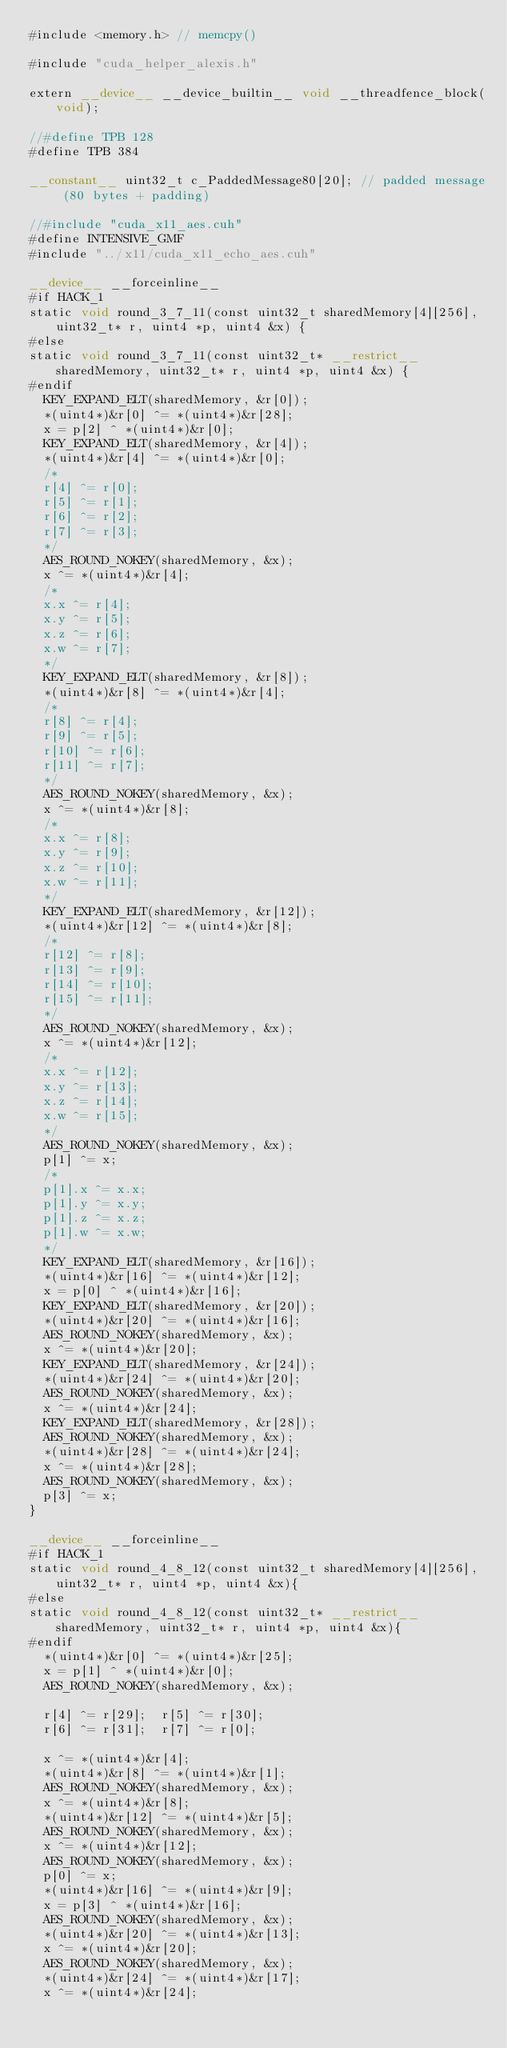Convert code to text. <code><loc_0><loc_0><loc_500><loc_500><_Cuda_>#include <memory.h> // memcpy()

#include "cuda_helper_alexis.h"

extern __device__ __device_builtin__ void __threadfence_block(void);
 
//#define TPB 128
#define TPB 384

__constant__ uint32_t c_PaddedMessage80[20]; // padded message (80 bytes + padding)

//#include "cuda_x11_aes.cuh"
#define INTENSIVE_GMF
#include "../x11/cuda_x11_echo_aes.cuh"

__device__ __forceinline__
#if HACK_1
static void round_3_7_11(const uint32_t sharedMemory[4][256], uint32_t* r, uint4 *p, uint4 &x) {
#else
static void round_3_7_11(const uint32_t* __restrict__ sharedMemory, uint32_t* r, uint4 *p, uint4 &x) {
#endif
	KEY_EXPAND_ELT(sharedMemory, &r[0]);
	*(uint4*)&r[0] ^= *(uint4*)&r[28];
	x = p[2] ^ *(uint4*)&r[0];
	KEY_EXPAND_ELT(sharedMemory, &r[4]);
	*(uint4*)&r[4] ^= *(uint4*)&r[0];
	/*
	r[4] ^= r[0];
	r[5] ^= r[1];
	r[6] ^= r[2];
	r[7] ^= r[3];
	*/
	AES_ROUND_NOKEY(sharedMemory, &x);
	x ^= *(uint4*)&r[4];
	/*
	x.x ^= r[4];
	x.y ^= r[5];
	x.z ^= r[6];
	x.w ^= r[7];
	*/
	KEY_EXPAND_ELT(sharedMemory, &r[8]);
	*(uint4*)&r[8] ^= *(uint4*)&r[4];
	/*
	r[8] ^= r[4];
	r[9] ^= r[5];
	r[10] ^= r[6];
	r[11] ^= r[7];
	*/
	AES_ROUND_NOKEY(sharedMemory, &x);
	x ^= *(uint4*)&r[8];
	/*
	x.x ^= r[8];
	x.y ^= r[9];
	x.z ^= r[10];
	x.w ^= r[11];
	*/
	KEY_EXPAND_ELT(sharedMemory, &r[12]);
	*(uint4*)&r[12] ^= *(uint4*)&r[8];
	/*
	r[12] ^= r[8];
	r[13] ^= r[9];
	r[14] ^= r[10];
	r[15] ^= r[11];
	*/
	AES_ROUND_NOKEY(sharedMemory, &x);
	x ^= *(uint4*)&r[12];
	/*
	x.x ^= r[12];
	x.y ^= r[13];
	x.z ^= r[14];
	x.w ^= r[15];
	*/
	AES_ROUND_NOKEY(sharedMemory, &x);
	p[1] ^= x;
	/*
	p[1].x ^= x.x;
	p[1].y ^= x.y;
	p[1].z ^= x.z;
	p[1].w ^= x.w;
	*/
	KEY_EXPAND_ELT(sharedMemory, &r[16]);
	*(uint4*)&r[16] ^= *(uint4*)&r[12];
	x = p[0] ^ *(uint4*)&r[16];
	KEY_EXPAND_ELT(sharedMemory, &r[20]);
	*(uint4*)&r[20] ^= *(uint4*)&r[16];
	AES_ROUND_NOKEY(sharedMemory, &x);
	x ^= *(uint4*)&r[20];
	KEY_EXPAND_ELT(sharedMemory, &r[24]);
	*(uint4*)&r[24] ^= *(uint4*)&r[20];
	AES_ROUND_NOKEY(sharedMemory, &x);
	x ^= *(uint4*)&r[24];
	KEY_EXPAND_ELT(sharedMemory, &r[28]);
	AES_ROUND_NOKEY(sharedMemory, &x);
	*(uint4*)&r[28] ^= *(uint4*)&r[24];
	x ^= *(uint4*)&r[28];
	AES_ROUND_NOKEY(sharedMemory, &x);
	p[3] ^= x;
}

__device__ __forceinline__
#if HACK_1
static void round_4_8_12(const uint32_t sharedMemory[4][256], uint32_t* r, uint4 *p, uint4 &x){
#else
static void round_4_8_12(const uint32_t* __restrict__ sharedMemory, uint32_t* r, uint4 *p, uint4 &x){
#endif
	*(uint4*)&r[0] ^= *(uint4*)&r[25];
	x = p[1] ^ *(uint4*)&r[0];
	AES_ROUND_NOKEY(sharedMemory, &x);

	r[4] ^= r[29];	r[5] ^= r[30];
	r[6] ^= r[31];	r[7] ^= r[0];

	x ^= *(uint4*)&r[4];
	*(uint4*)&r[8] ^= *(uint4*)&r[1];
	AES_ROUND_NOKEY(sharedMemory, &x);
	x ^= *(uint4*)&r[8];
	*(uint4*)&r[12] ^= *(uint4*)&r[5];
	AES_ROUND_NOKEY(sharedMemory, &x);
	x ^= *(uint4*)&r[12];
	AES_ROUND_NOKEY(sharedMemory, &x);
	p[0] ^= x;
	*(uint4*)&r[16] ^= *(uint4*)&r[9];
	x = p[3] ^ *(uint4*)&r[16];
	AES_ROUND_NOKEY(sharedMemory, &x);
	*(uint4*)&r[20] ^= *(uint4*)&r[13];
	x ^= *(uint4*)&r[20];
	AES_ROUND_NOKEY(sharedMemory, &x);
	*(uint4*)&r[24] ^= *(uint4*)&r[17];
	x ^= *(uint4*)&r[24];</code> 